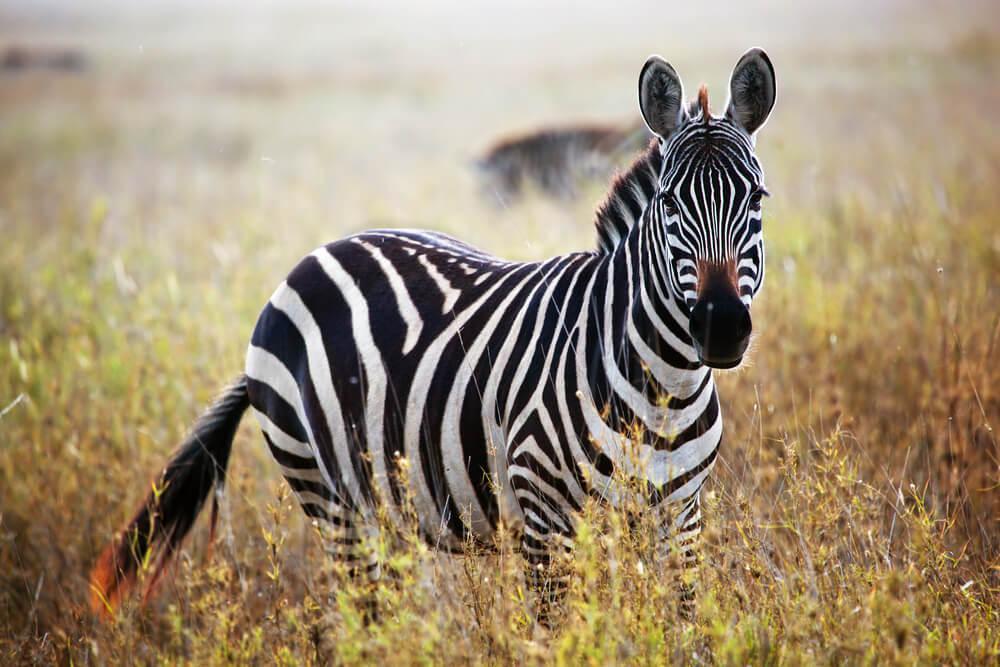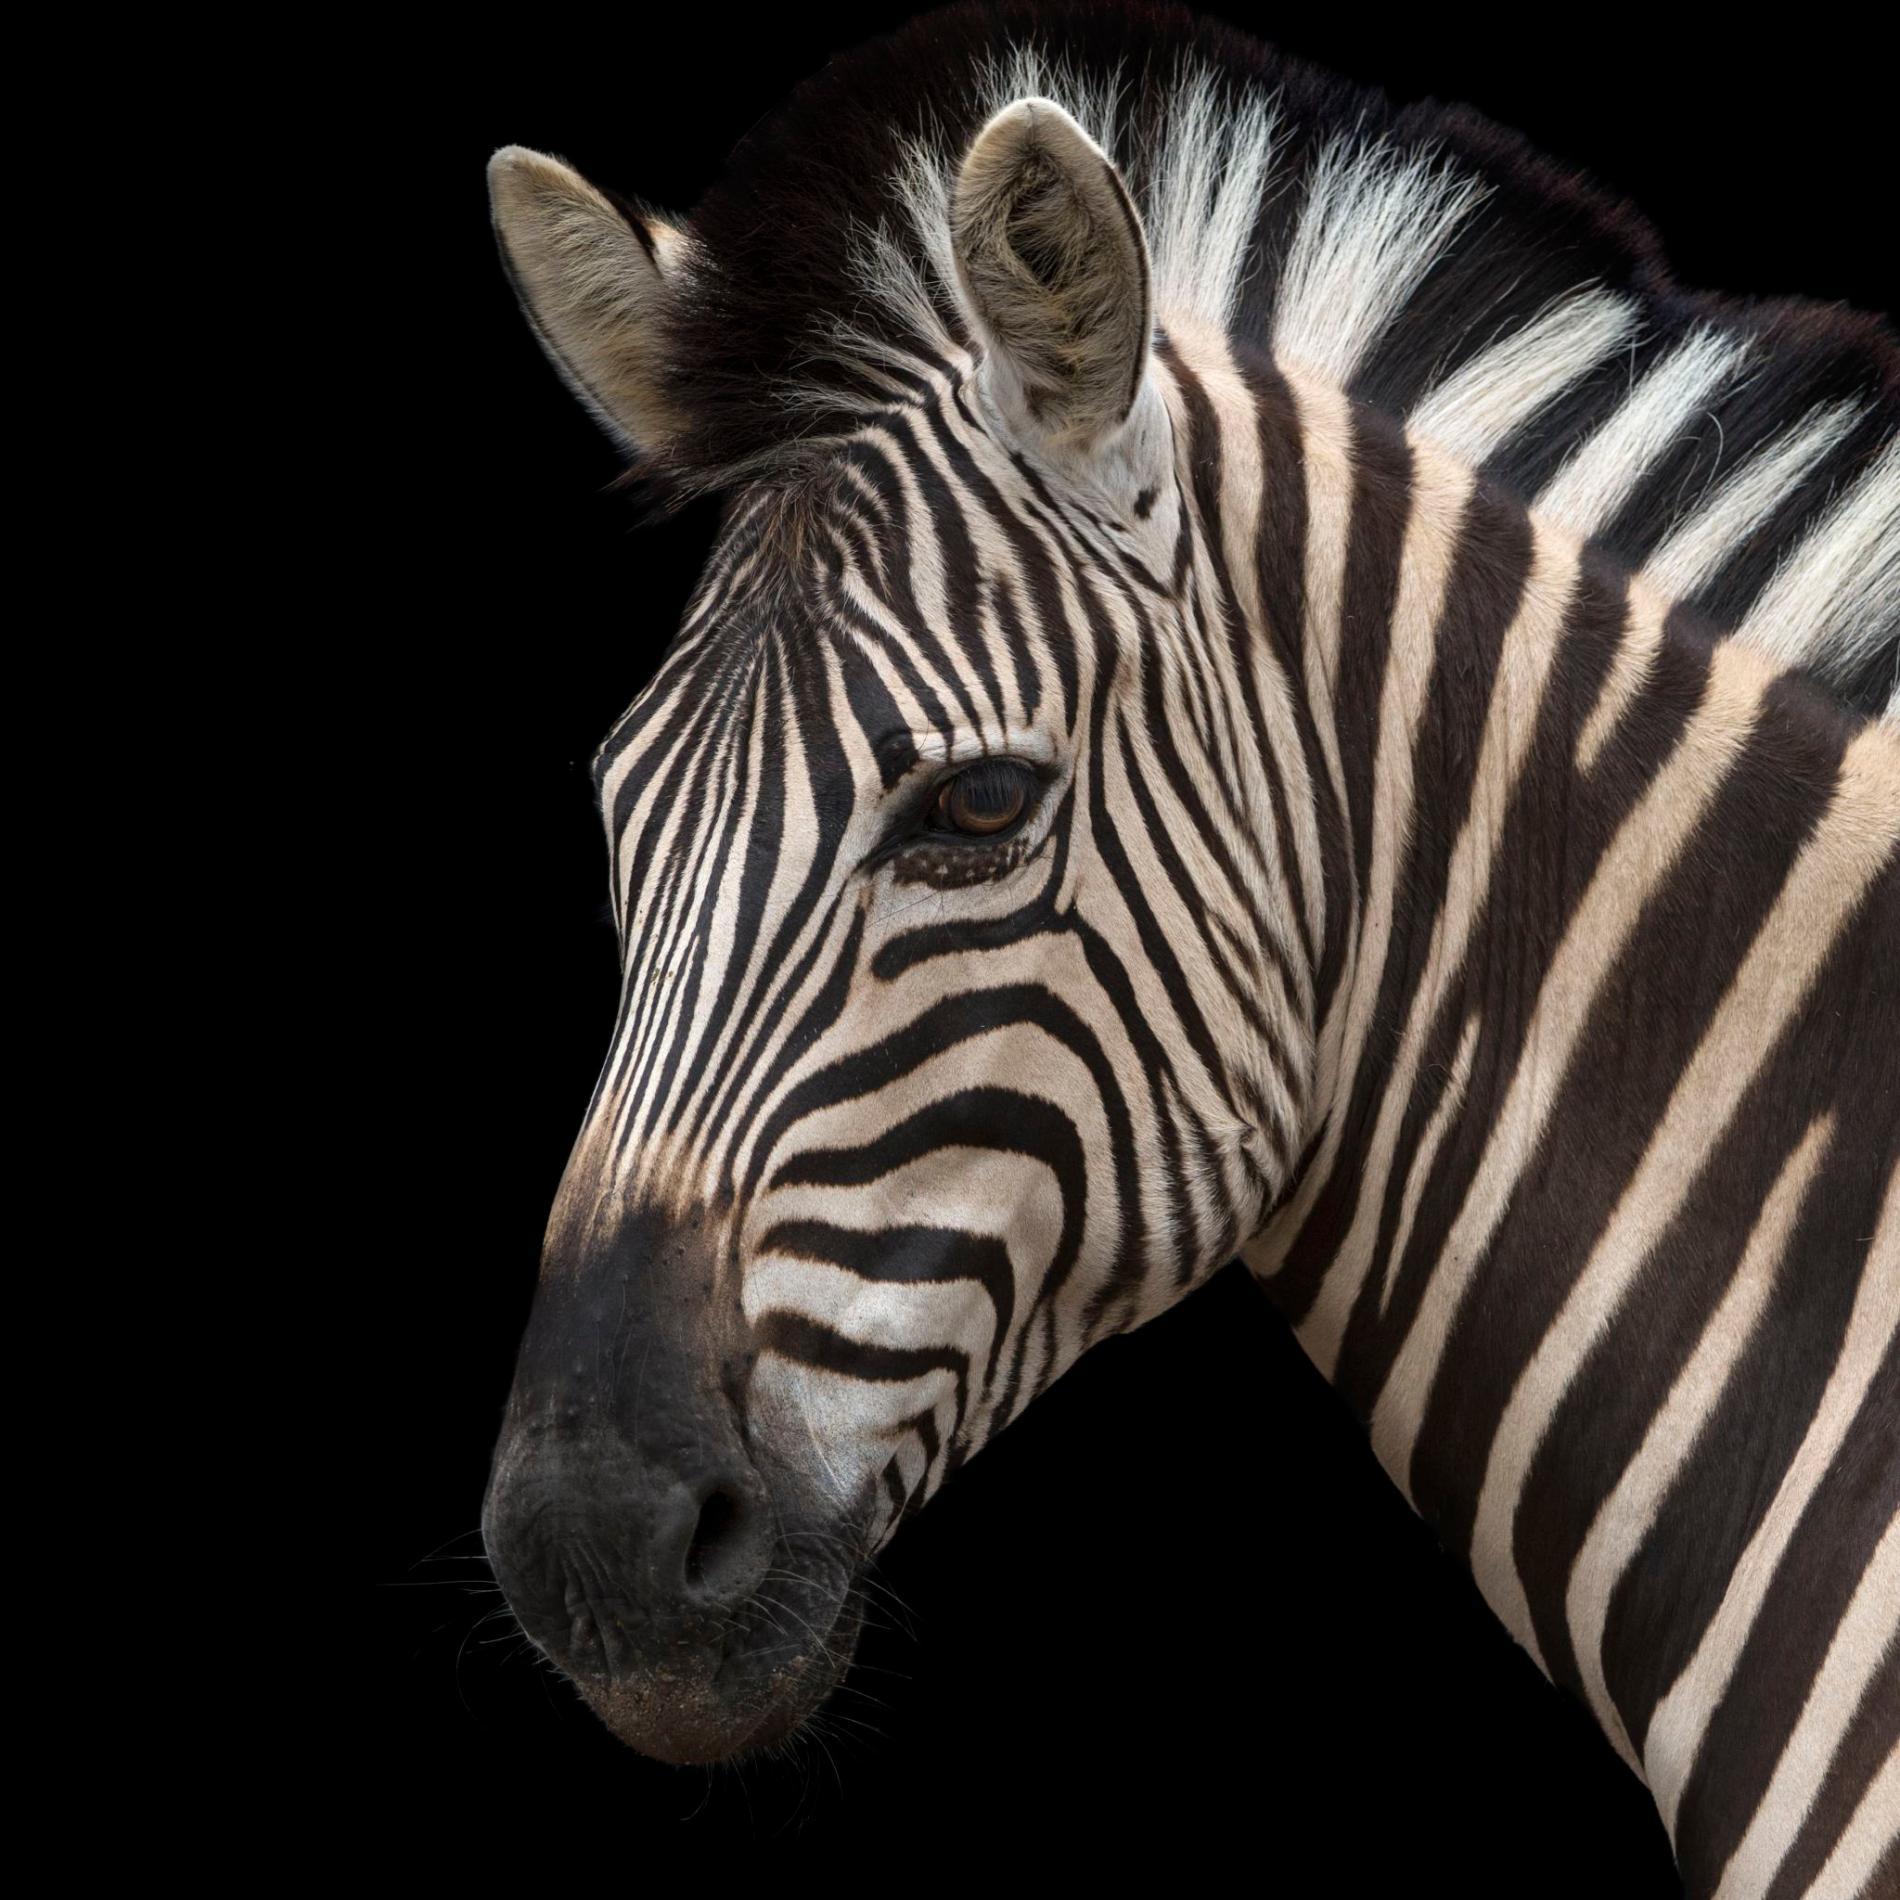The first image is the image on the left, the second image is the image on the right. Evaluate the accuracy of this statement regarding the images: "There is a mother zebra standing in the grass with her baby close to her". Is it true? Answer yes or no. No. The first image is the image on the left, the second image is the image on the right. Assess this claim about the two images: "The right image contains only one zebra.". Correct or not? Answer yes or no. Yes. 